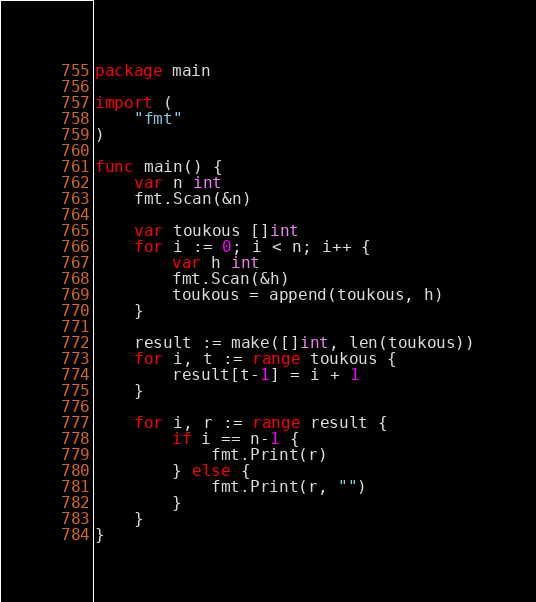<code> <loc_0><loc_0><loc_500><loc_500><_Go_>package main

import (
	"fmt"
)

func main() {
	var n int
	fmt.Scan(&n)

	var toukous []int
	for i := 0; i < n; i++ {
		var h int
		fmt.Scan(&h)
		toukous = append(toukous, h)
	}

	result := make([]int, len(toukous))
	for i, t := range toukous {
		result[t-1] = i + 1
	}

	for i, r := range result {
		if i == n-1 {
			fmt.Print(r)
		} else {
			fmt.Print(r, "")
		}
	}
}
</code> 